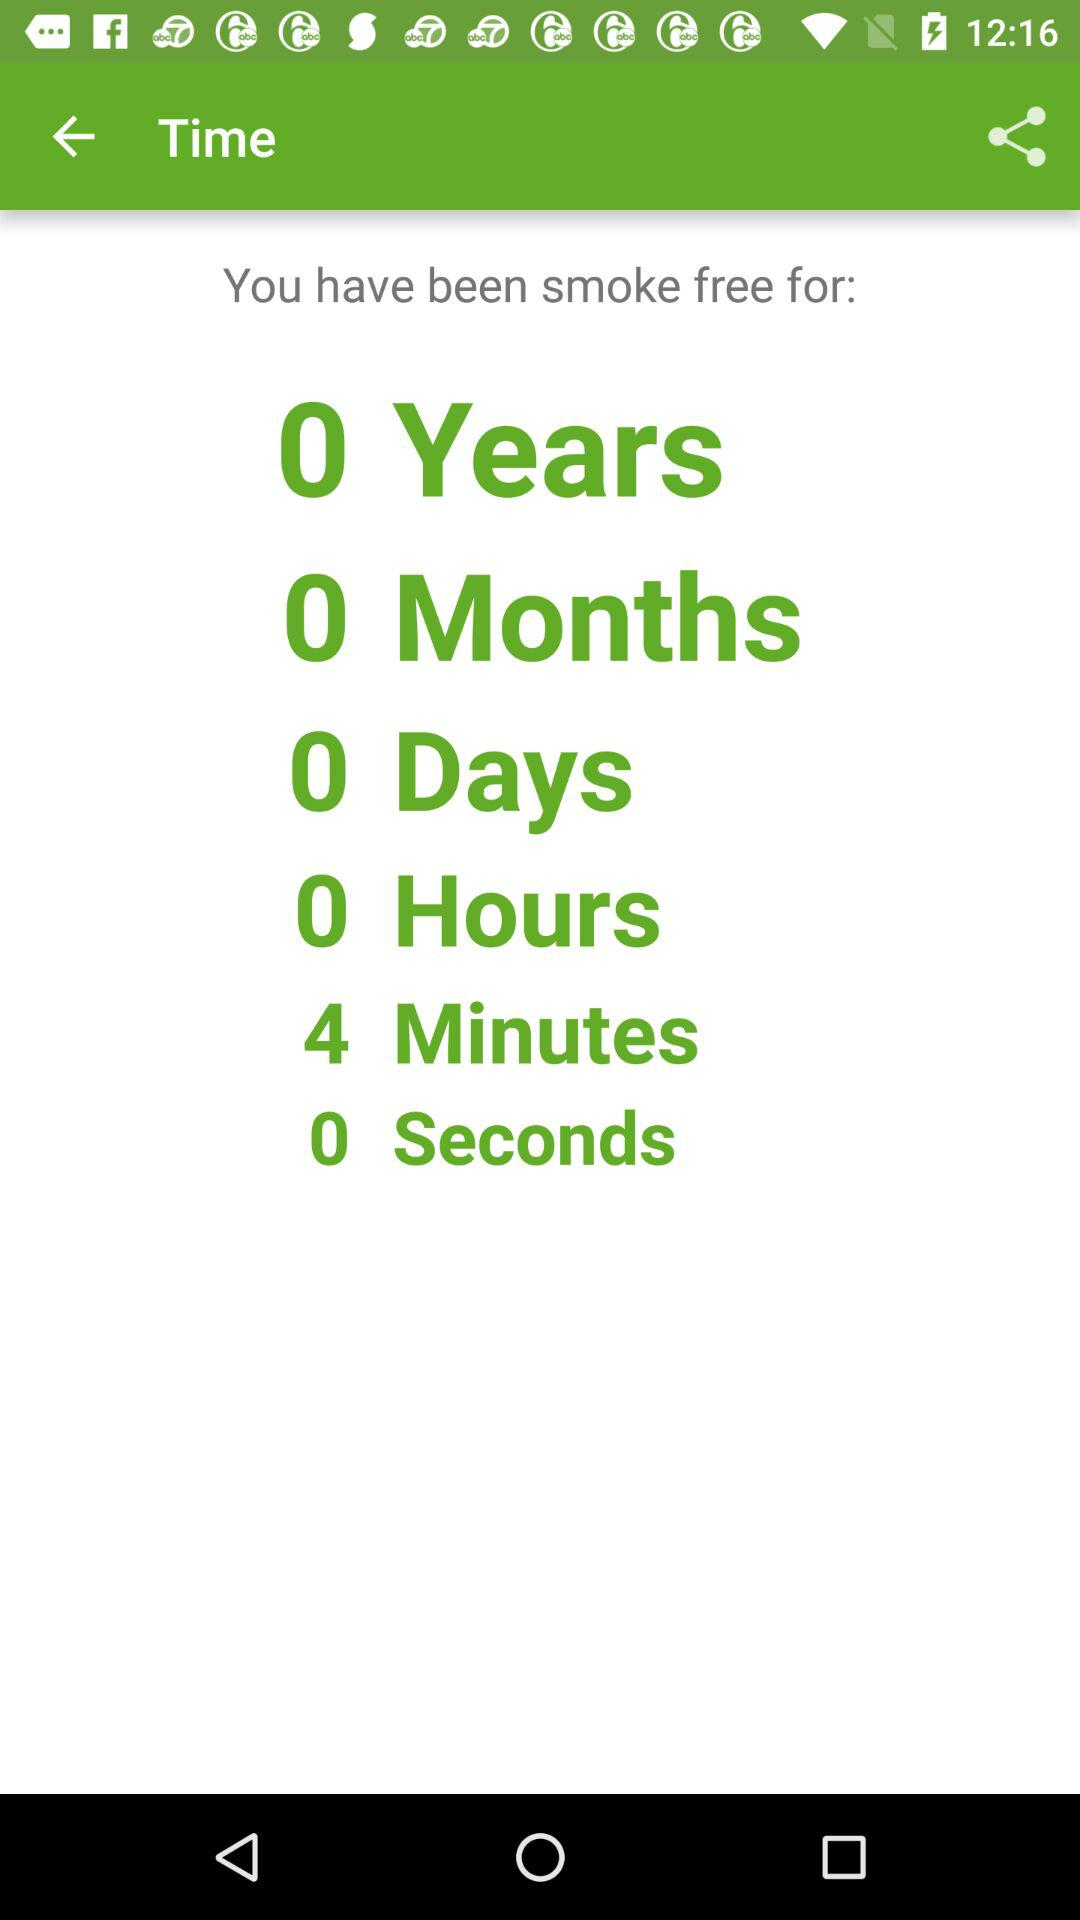How many more minutes than seconds have I been smoke free?
Answer the question using a single word or phrase. 4 